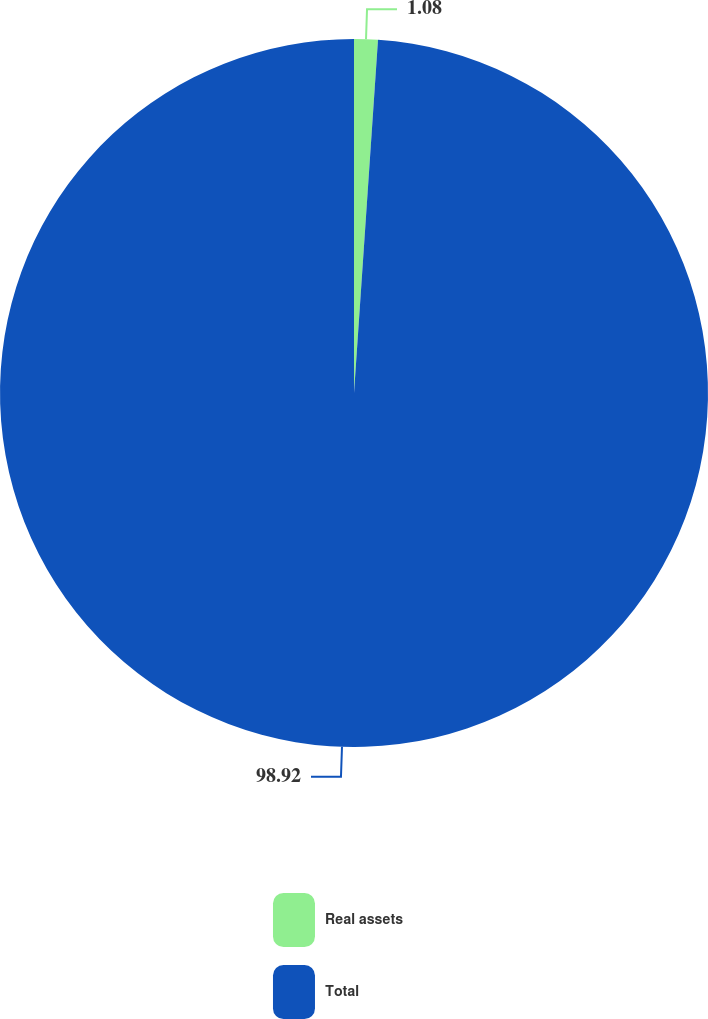Convert chart to OTSL. <chart><loc_0><loc_0><loc_500><loc_500><pie_chart><fcel>Real assets<fcel>Total<nl><fcel>1.08%<fcel>98.92%<nl></chart> 